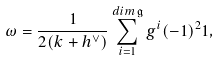<formula> <loc_0><loc_0><loc_500><loc_500>\omega = \frac { 1 } { 2 ( k + h ^ { \vee } ) } \sum _ { i = 1 } ^ { d i m \, \mathfrak { g } } g ^ { i } ( - 1 ) ^ { 2 } { 1 } ,</formula> 